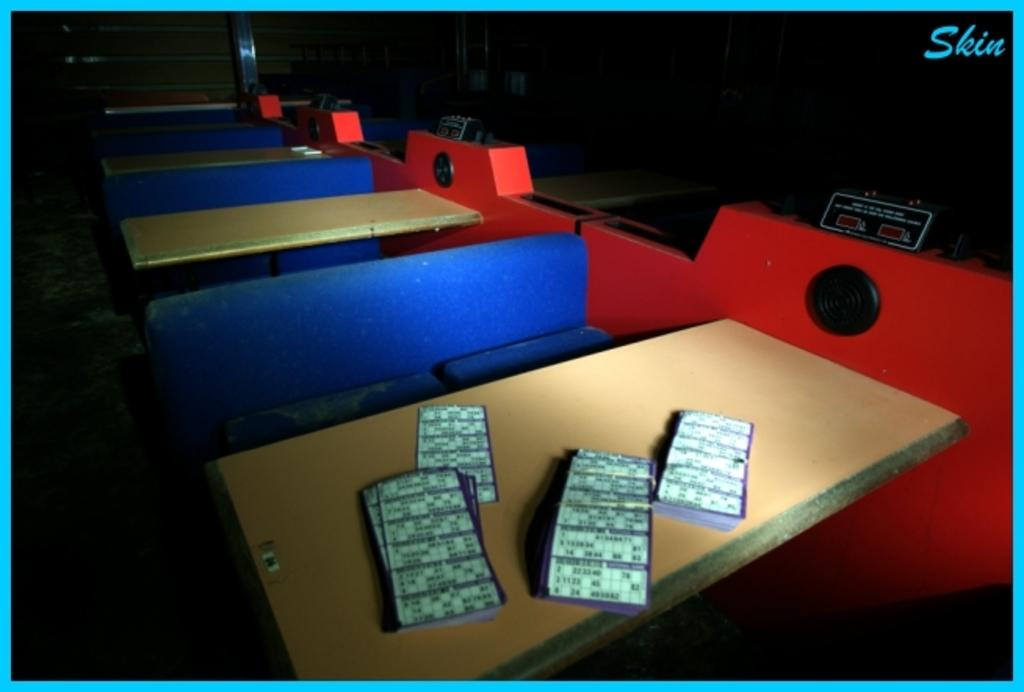What is on the table in the image? There are Housie game tickets on the table. What can be seen in the background of the image? There are tables, benches, and machines in the background of the image. Can you describe the watermark on the image? The watermark is a design or text that is visible on the image. What type of industry is being operated in the image? There is no indication of an industry or operation in the image; it primarily features Housie game tickets and background elements. Can you tell me how many bottles are visible in the image? There are no bottles present in the image. 